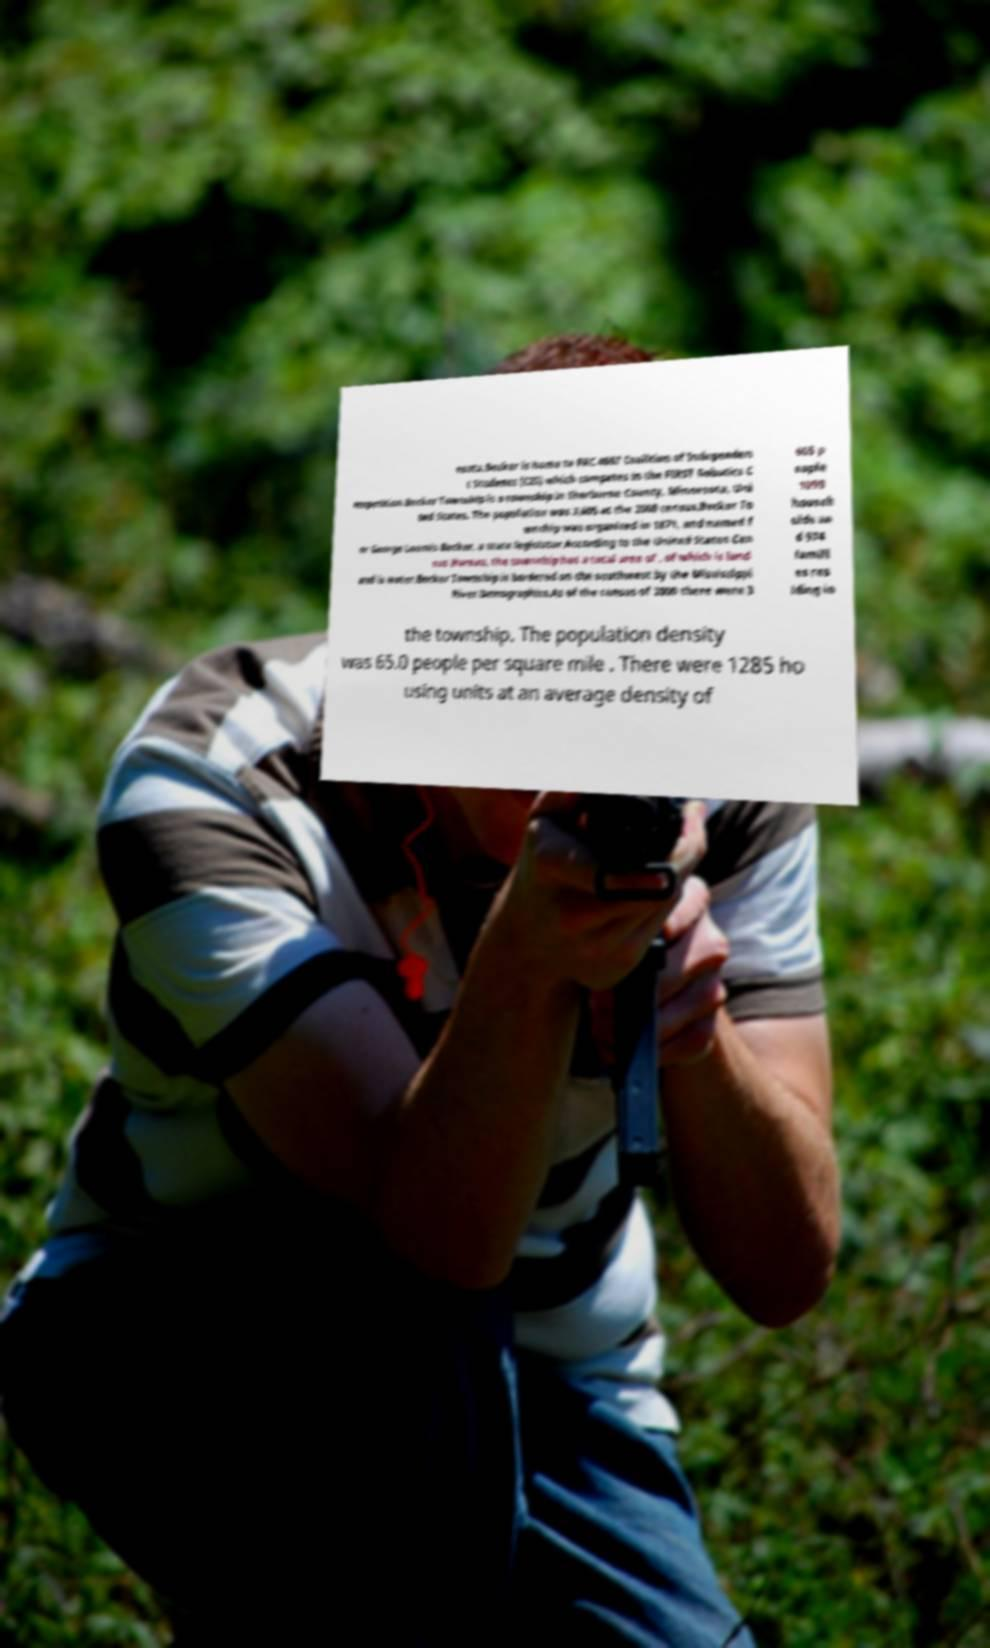There's text embedded in this image that I need extracted. Can you transcribe it verbatim? esota.Becker is home to FRC 4607 Coalition of Independen t Students (CIS) which competes in the FIRST Robotics C ompetition.Becker Township is a township in Sherburne County, Minnesota, Uni ted States. The population was 3,605 at the 2000 census.Becker To wnship was organized in 1871, and named f or George Loomis Becker, a state legislator.According to the United States Cen sus Bureau, the township has a total area of , of which is land and is water.Becker Township is bordered on the southwest by the Mississippi River.Demographics.As of the census of 2000 there were 3 605 p eople 1099 househ olds an d 974 famili es res iding in the township. The population density was 65.0 people per square mile . There were 1285 ho using units at an average density of 